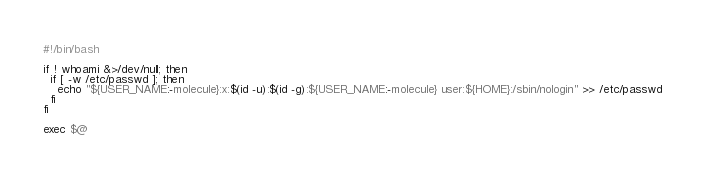Convert code to text. <code><loc_0><loc_0><loc_500><loc_500><_Bash_>#!/bin/bash

if ! whoami &>/dev/null; then
  if [ -w /etc/passwd ]; then
    echo "${USER_NAME:-molecule}:x:$(id -u):$(id -g):${USER_NAME:-molecule} user:${HOME}:/sbin/nologin" >> /etc/passwd
  fi
fi

exec $@
</code> 